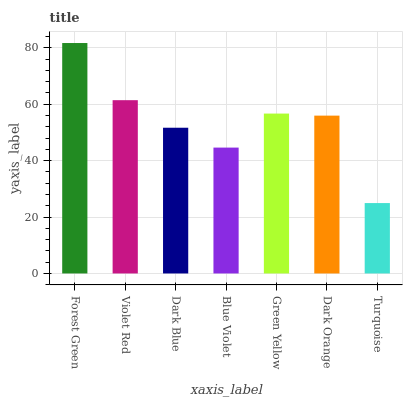Is Violet Red the minimum?
Answer yes or no. No. Is Violet Red the maximum?
Answer yes or no. No. Is Forest Green greater than Violet Red?
Answer yes or no. Yes. Is Violet Red less than Forest Green?
Answer yes or no. Yes. Is Violet Red greater than Forest Green?
Answer yes or no. No. Is Forest Green less than Violet Red?
Answer yes or no. No. Is Dark Orange the high median?
Answer yes or no. Yes. Is Dark Orange the low median?
Answer yes or no. Yes. Is Blue Violet the high median?
Answer yes or no. No. Is Forest Green the low median?
Answer yes or no. No. 